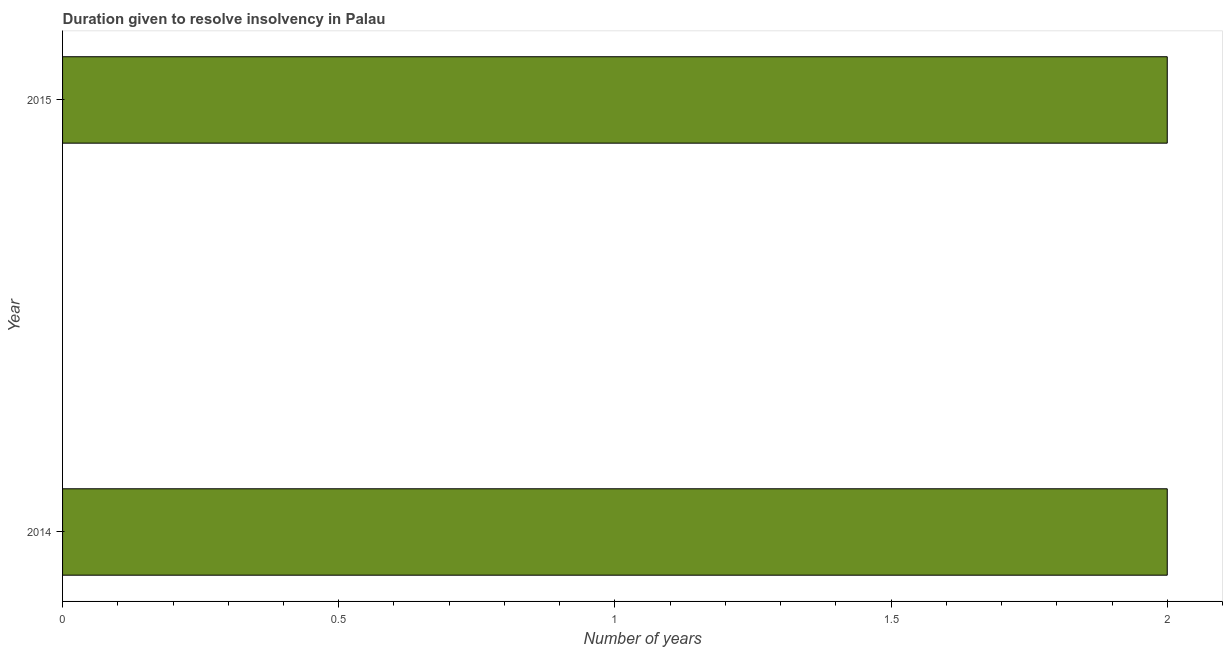What is the title of the graph?
Ensure brevity in your answer.  Duration given to resolve insolvency in Palau. What is the label or title of the X-axis?
Provide a short and direct response. Number of years. What is the label or title of the Y-axis?
Your response must be concise. Year. Across all years, what is the maximum number of years to resolve insolvency?
Offer a terse response. 2. Across all years, what is the minimum number of years to resolve insolvency?
Your answer should be compact. 2. In which year was the number of years to resolve insolvency minimum?
Keep it short and to the point. 2014. What is the sum of the number of years to resolve insolvency?
Make the answer very short. 4. What is the median number of years to resolve insolvency?
Offer a very short reply. 2. What is the ratio of the number of years to resolve insolvency in 2014 to that in 2015?
Your answer should be very brief. 1. Are all the bars in the graph horizontal?
Keep it short and to the point. Yes. What is the difference between two consecutive major ticks on the X-axis?
Your answer should be very brief. 0.5. 